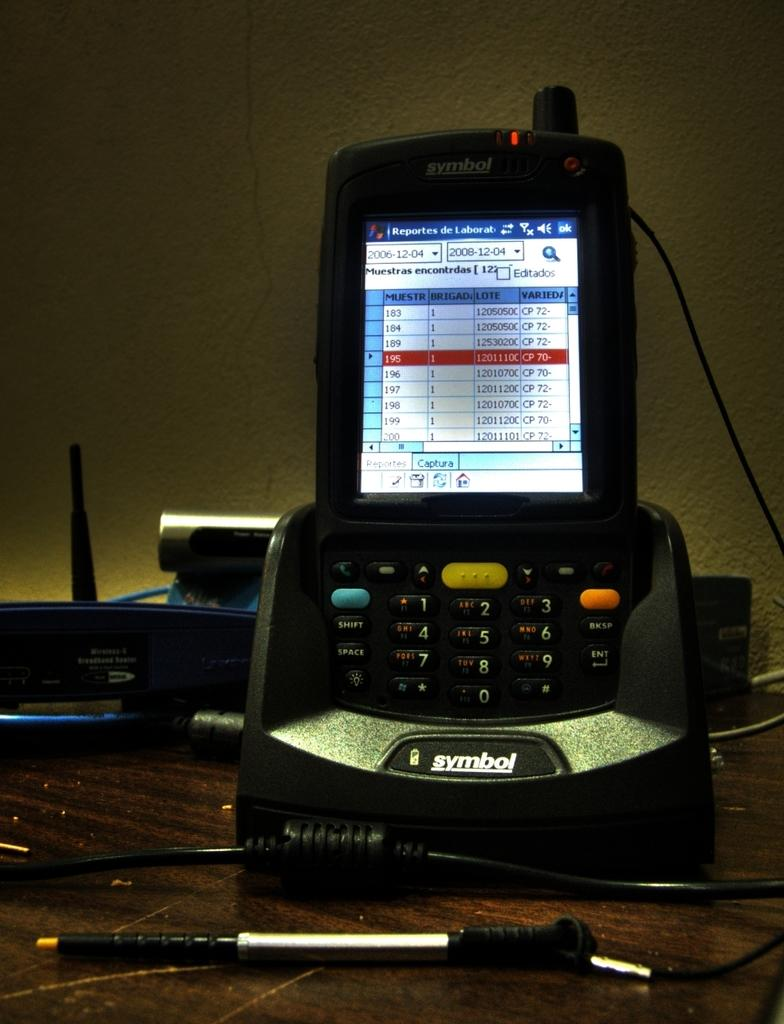<image>
Render a clear and concise summary of the photo. An electronic device made by Symbol is plugged into a connecting component made by the same company. 